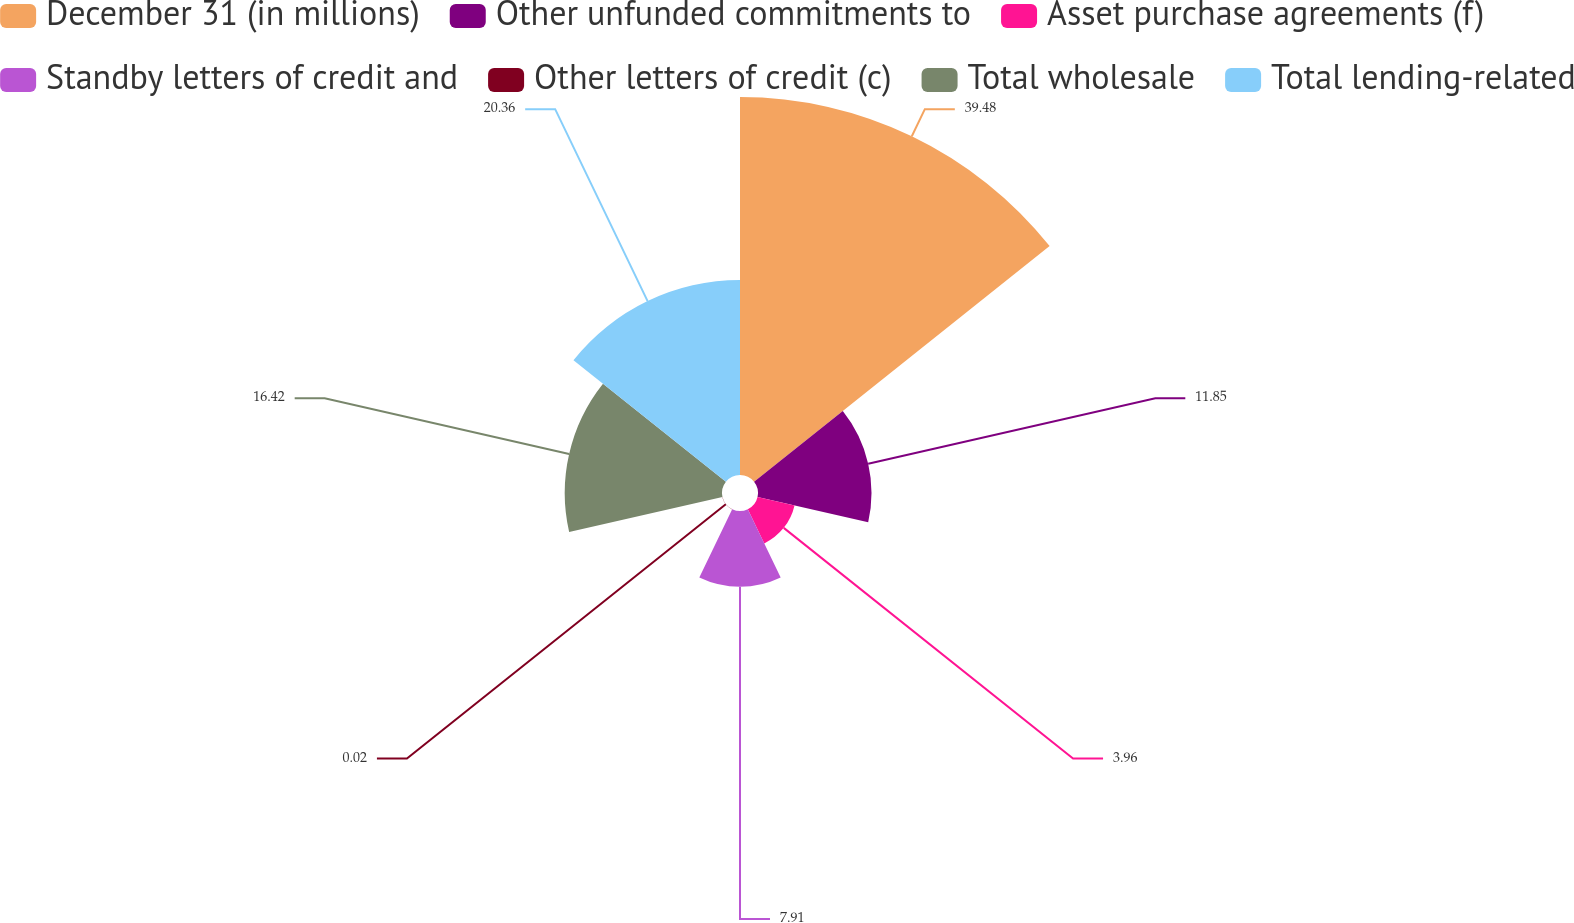Convert chart to OTSL. <chart><loc_0><loc_0><loc_500><loc_500><pie_chart><fcel>December 31 (in millions)<fcel>Other unfunded commitments to<fcel>Asset purchase agreements (f)<fcel>Standby letters of credit and<fcel>Other letters of credit (c)<fcel>Total wholesale<fcel>Total lending-related<nl><fcel>39.47%<fcel>11.85%<fcel>3.96%<fcel>7.91%<fcel>0.02%<fcel>16.42%<fcel>20.36%<nl></chart> 